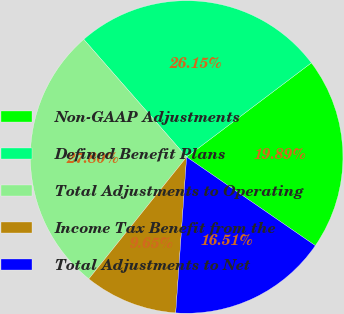Convert chart to OTSL. <chart><loc_0><loc_0><loc_500><loc_500><pie_chart><fcel>Non-GAAP Adjustments<fcel>Defined Benefit Plans<fcel>Total Adjustments to Operating<fcel>Income Tax Benefit from the<fcel>Total Adjustments to Net<nl><fcel>19.89%<fcel>26.15%<fcel>27.8%<fcel>9.65%<fcel>16.51%<nl></chart> 